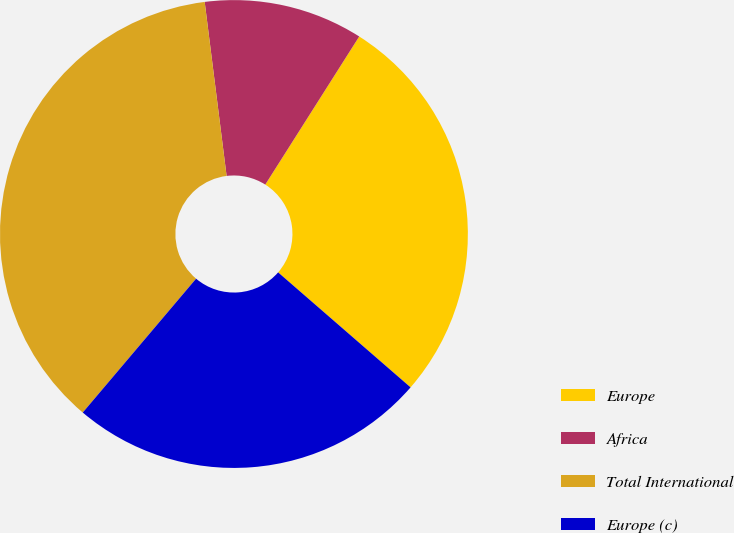Convert chart to OTSL. <chart><loc_0><loc_0><loc_500><loc_500><pie_chart><fcel>Europe<fcel>Africa<fcel>Total International<fcel>Europe (c)<nl><fcel>27.38%<fcel>10.99%<fcel>36.82%<fcel>24.8%<nl></chart> 